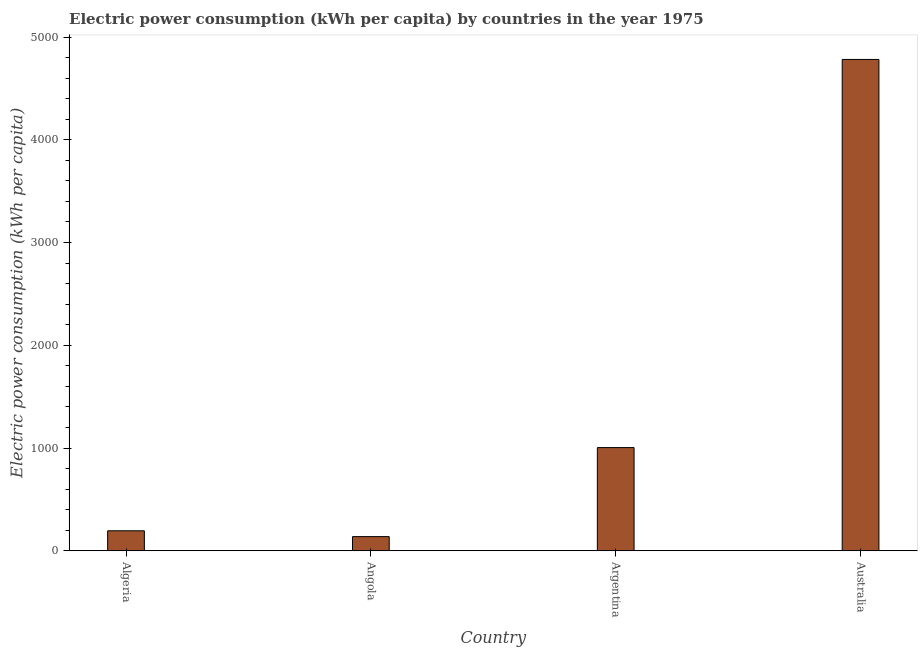Does the graph contain grids?
Provide a succinct answer. No. What is the title of the graph?
Provide a short and direct response. Electric power consumption (kWh per capita) by countries in the year 1975. What is the label or title of the Y-axis?
Make the answer very short. Electric power consumption (kWh per capita). What is the electric power consumption in Argentina?
Provide a short and direct response. 1004.18. Across all countries, what is the maximum electric power consumption?
Your answer should be very brief. 4781.62. Across all countries, what is the minimum electric power consumption?
Offer a terse response. 137.75. In which country was the electric power consumption maximum?
Give a very brief answer. Australia. In which country was the electric power consumption minimum?
Your answer should be compact. Angola. What is the sum of the electric power consumption?
Provide a short and direct response. 6118.05. What is the difference between the electric power consumption in Angola and Argentina?
Offer a terse response. -866.44. What is the average electric power consumption per country?
Keep it short and to the point. 1529.51. What is the median electric power consumption?
Provide a short and direct response. 599.34. In how many countries, is the electric power consumption greater than 1000 kWh per capita?
Your answer should be compact. 2. What is the ratio of the electric power consumption in Angola to that in Australia?
Provide a short and direct response. 0.03. What is the difference between the highest and the second highest electric power consumption?
Ensure brevity in your answer.  3777.43. What is the difference between the highest and the lowest electric power consumption?
Give a very brief answer. 4643.87. In how many countries, is the electric power consumption greater than the average electric power consumption taken over all countries?
Your response must be concise. 1. How many bars are there?
Provide a succinct answer. 4. Are all the bars in the graph horizontal?
Provide a succinct answer. No. How many countries are there in the graph?
Offer a very short reply. 4. What is the Electric power consumption (kWh per capita) of Algeria?
Offer a terse response. 194.5. What is the Electric power consumption (kWh per capita) in Angola?
Ensure brevity in your answer.  137.75. What is the Electric power consumption (kWh per capita) of Argentina?
Your answer should be compact. 1004.18. What is the Electric power consumption (kWh per capita) in Australia?
Keep it short and to the point. 4781.62. What is the difference between the Electric power consumption (kWh per capita) in Algeria and Angola?
Offer a very short reply. 56.76. What is the difference between the Electric power consumption (kWh per capita) in Algeria and Argentina?
Ensure brevity in your answer.  -809.68. What is the difference between the Electric power consumption (kWh per capita) in Algeria and Australia?
Your response must be concise. -4587.11. What is the difference between the Electric power consumption (kWh per capita) in Angola and Argentina?
Keep it short and to the point. -866.44. What is the difference between the Electric power consumption (kWh per capita) in Angola and Australia?
Your response must be concise. -4643.87. What is the difference between the Electric power consumption (kWh per capita) in Argentina and Australia?
Your response must be concise. -3777.43. What is the ratio of the Electric power consumption (kWh per capita) in Algeria to that in Angola?
Offer a very short reply. 1.41. What is the ratio of the Electric power consumption (kWh per capita) in Algeria to that in Argentina?
Offer a terse response. 0.19. What is the ratio of the Electric power consumption (kWh per capita) in Algeria to that in Australia?
Your answer should be compact. 0.04. What is the ratio of the Electric power consumption (kWh per capita) in Angola to that in Argentina?
Make the answer very short. 0.14. What is the ratio of the Electric power consumption (kWh per capita) in Angola to that in Australia?
Make the answer very short. 0.03. What is the ratio of the Electric power consumption (kWh per capita) in Argentina to that in Australia?
Provide a short and direct response. 0.21. 